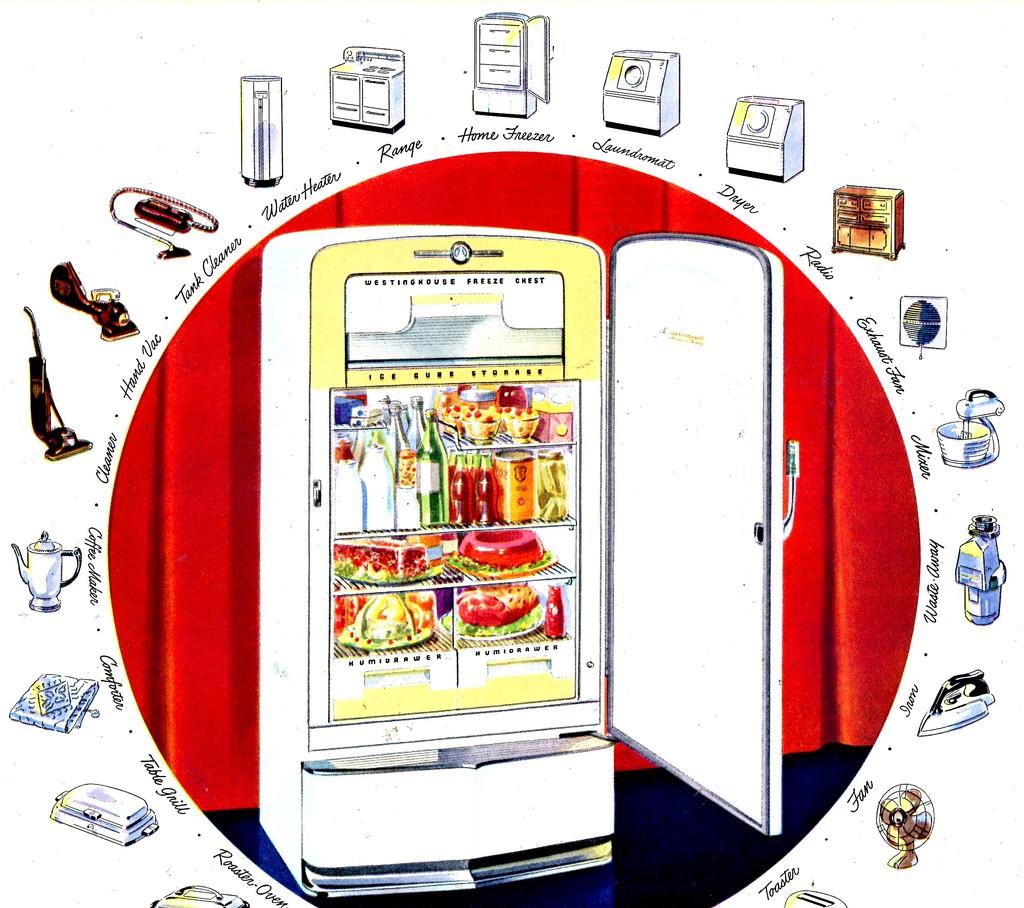Is this a new kitchen model?
Your answer should be compact. No. What other kind of kitchen appliance is featured?
Your answer should be very brief. Range. 